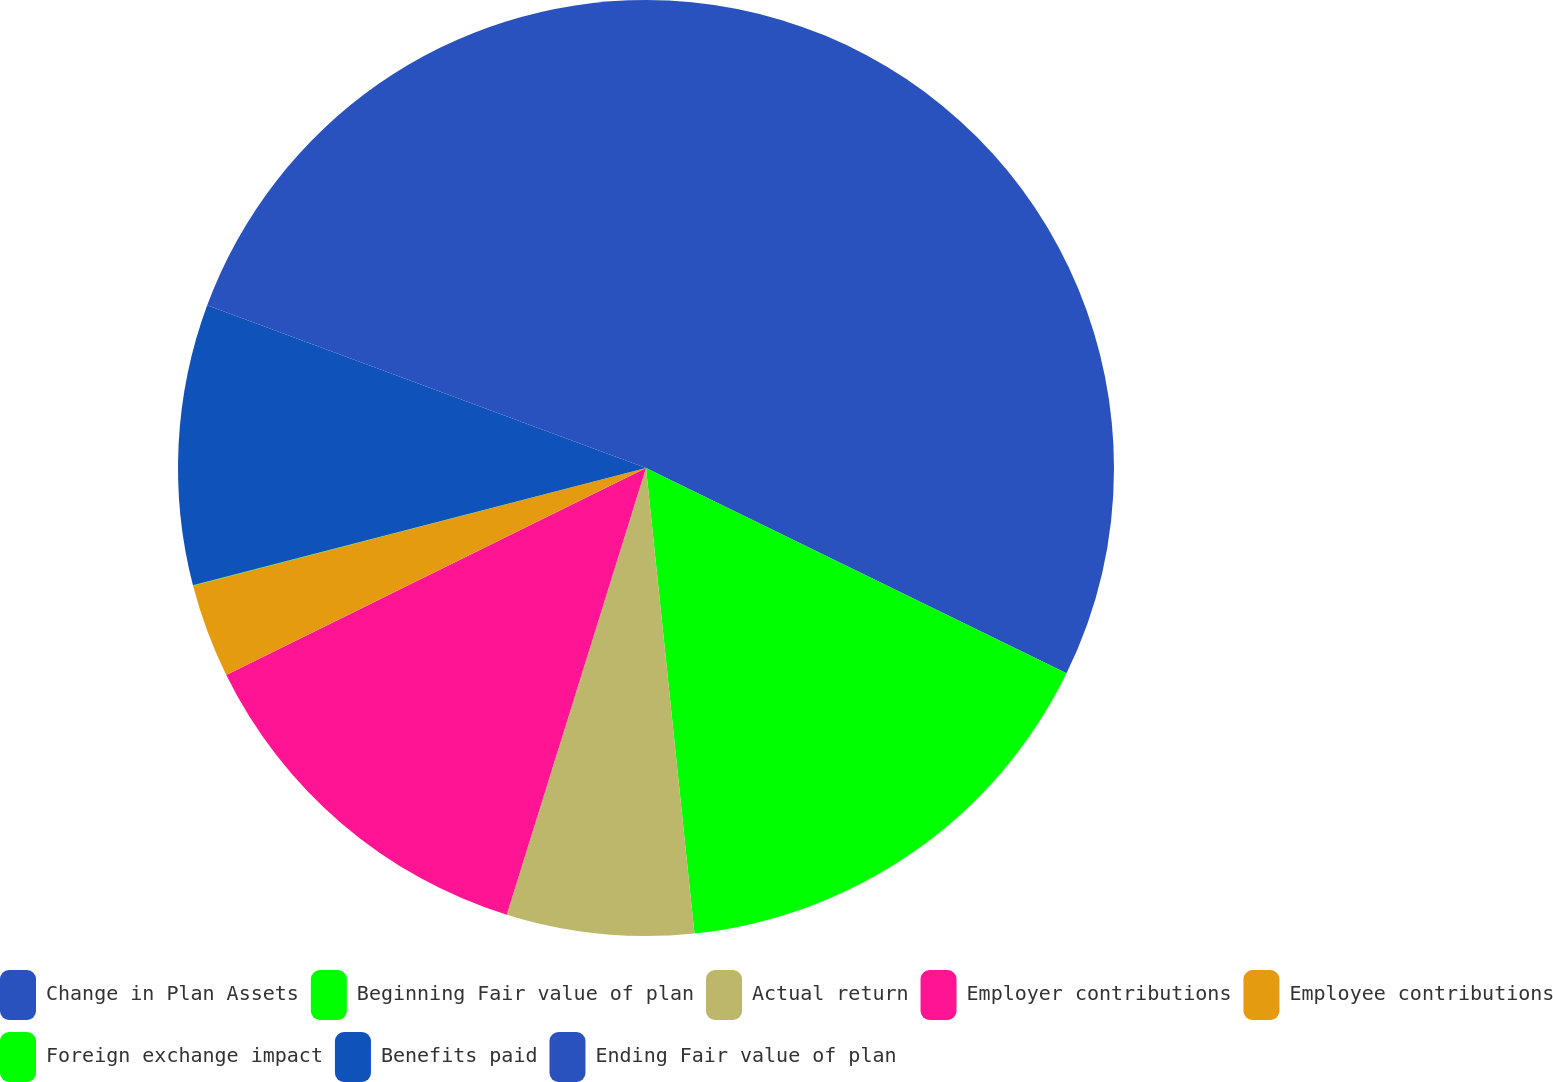Convert chart. <chart><loc_0><loc_0><loc_500><loc_500><pie_chart><fcel>Change in Plan Assets<fcel>Beginning Fair value of plan<fcel>Actual return<fcel>Employer contributions<fcel>Employee contributions<fcel>Foreign exchange impact<fcel>Benefits paid<fcel>Ending Fair value of plan<nl><fcel>32.23%<fcel>16.12%<fcel>6.46%<fcel>12.9%<fcel>3.24%<fcel>0.02%<fcel>9.68%<fcel>19.35%<nl></chart> 